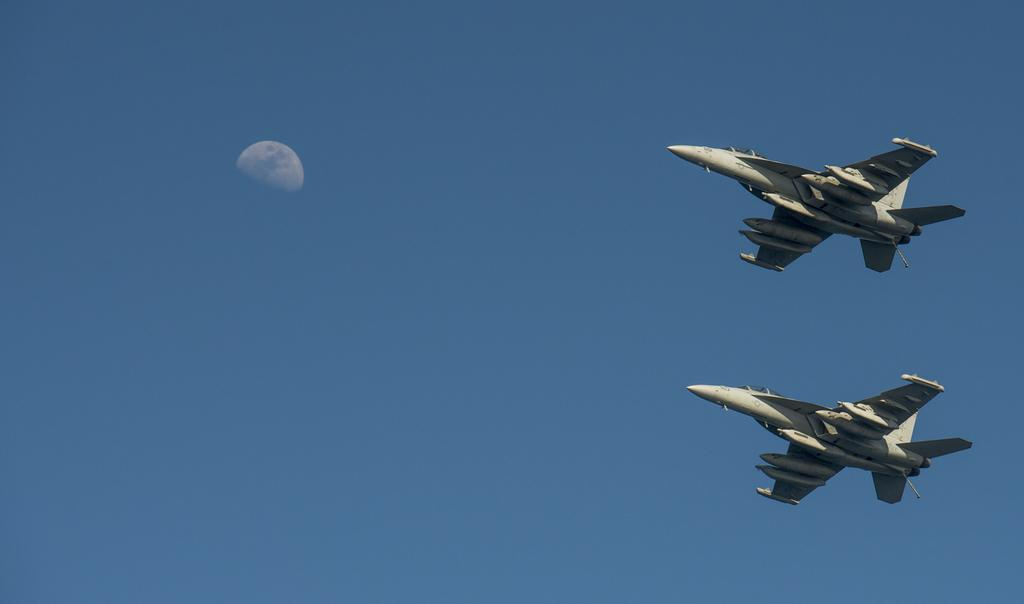What is the main subject of the image? The main subject of the image is two aircrafts. Where are the aircrafts located in the image? The aircrafts are in the air. What is the color of the sky in the image? The sky is blue in the image. What type of milk is being served on the aircrafts in the image? There is no milk or any indication of food or drink being served on the aircrafts in the image. 